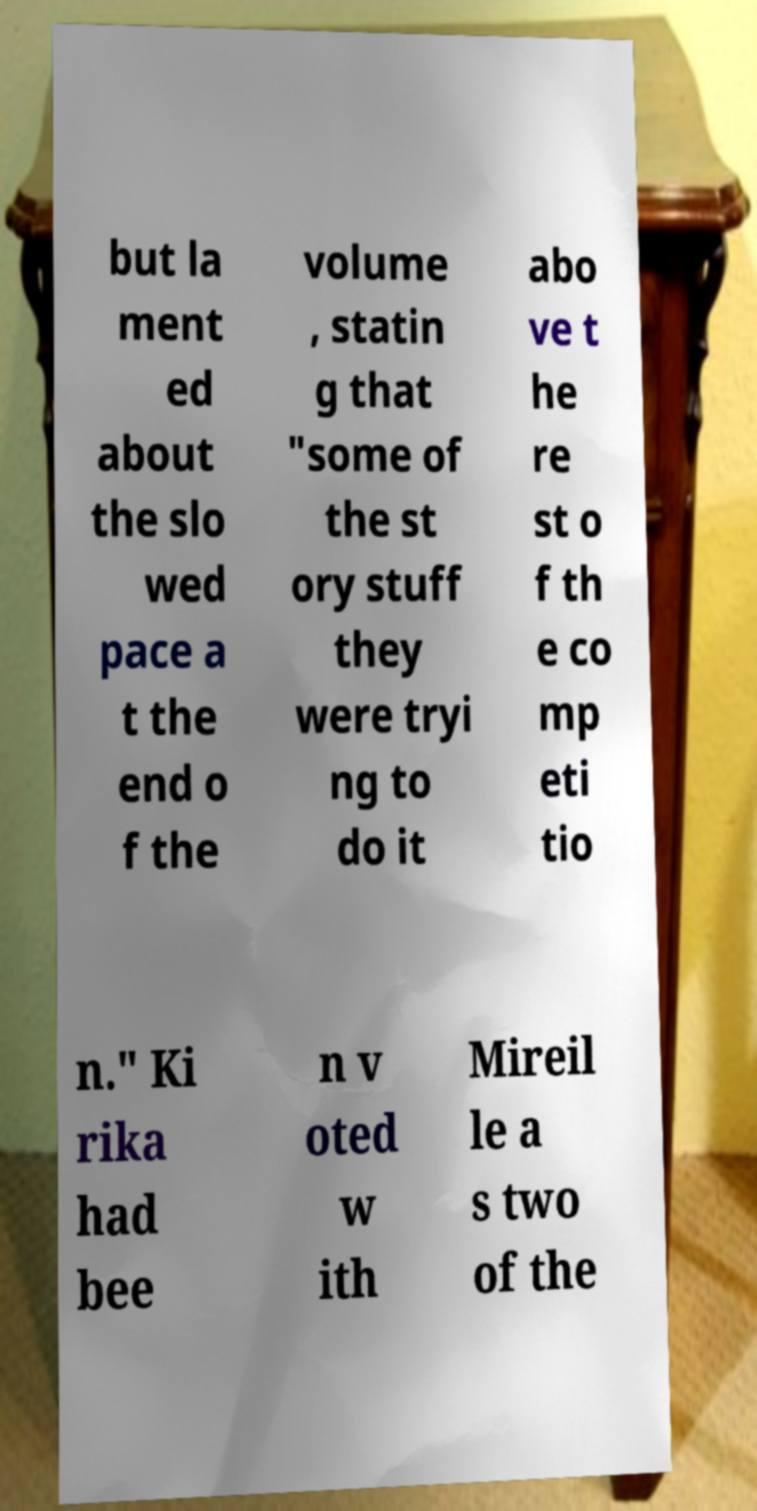There's text embedded in this image that I need extracted. Can you transcribe it verbatim? but la ment ed about the slo wed pace a t the end o f the volume , statin g that "some of the st ory stuff they were tryi ng to do it abo ve t he re st o f th e co mp eti tio n." Ki rika had bee n v oted w ith Mireil le a s two of the 